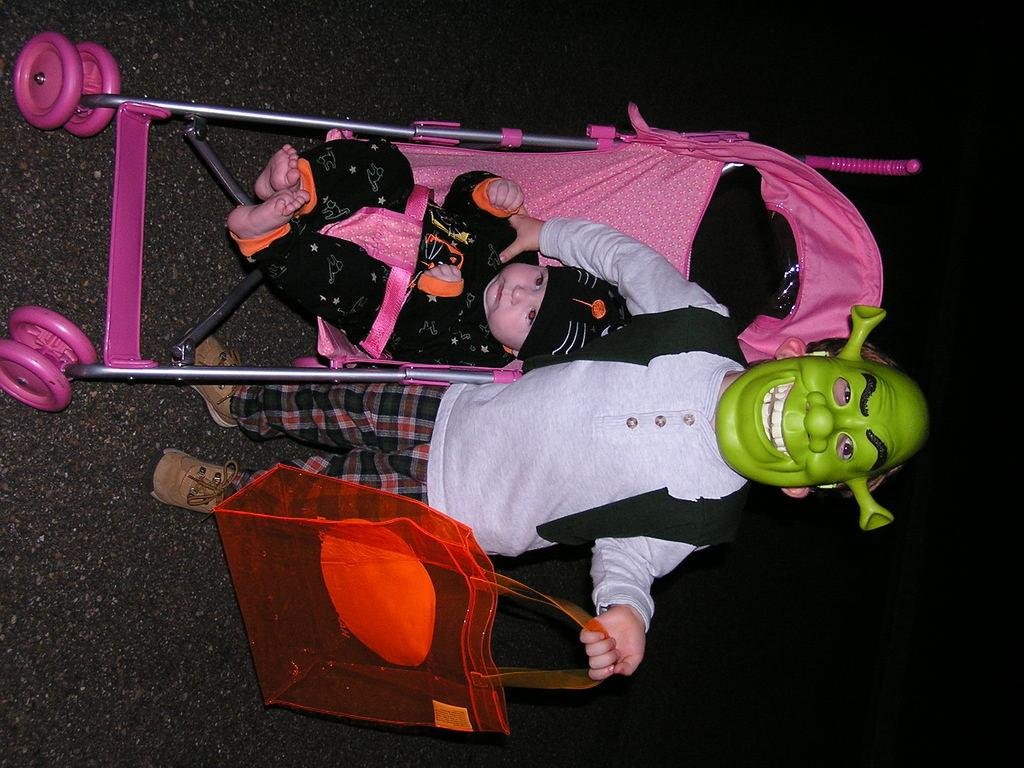What is the person in the image wearing on their face? The person is wearing a mask in the image. What is the person holding in their hand? The person is holding a bag in the image. What is the kid doing in the image? The kid is sitting in a trolley in the image. What can be seen at the bottom of the image? There is a road at the bottom of the image. What language is the person speaking in the image? There is no indication of the person speaking in the image, so it cannot be determined what language they might be using. 